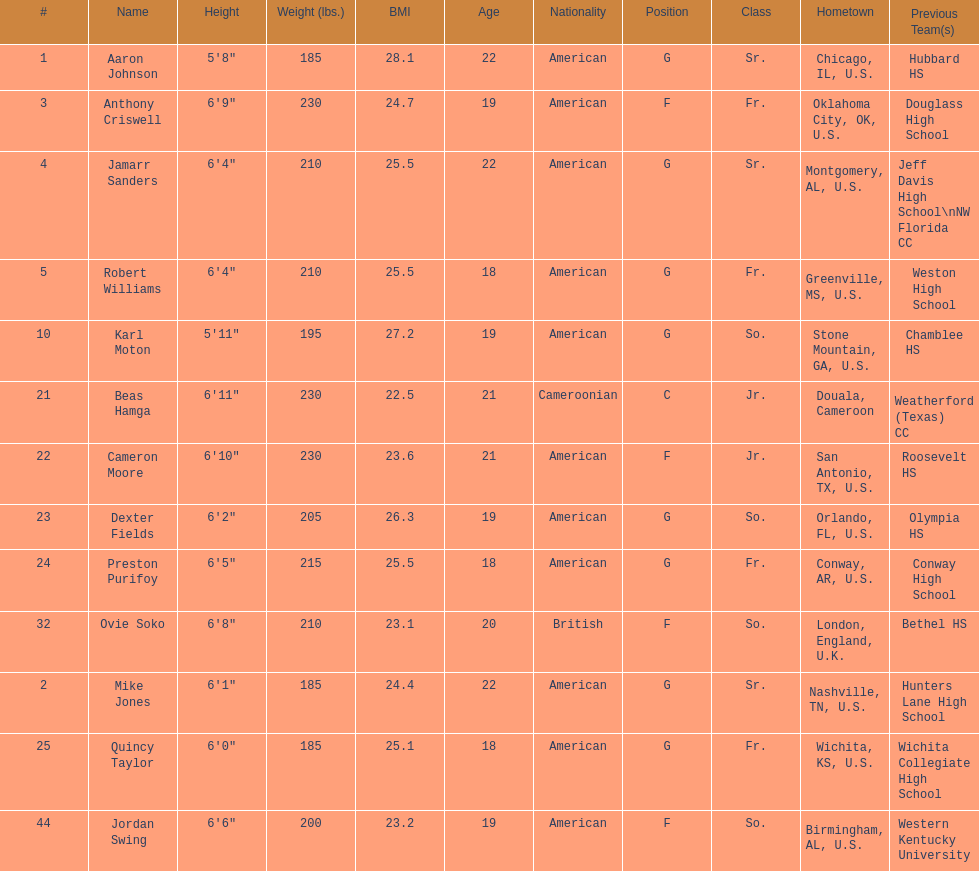What is the number of seniors on the team? 3. 